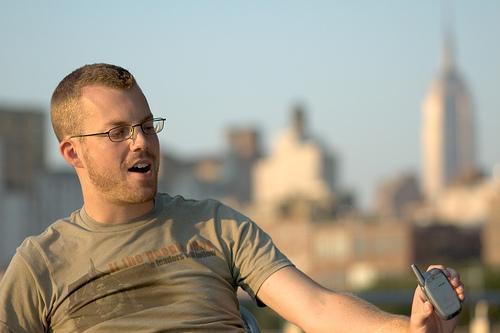How many people are shown?
Give a very brief answer. 1. 